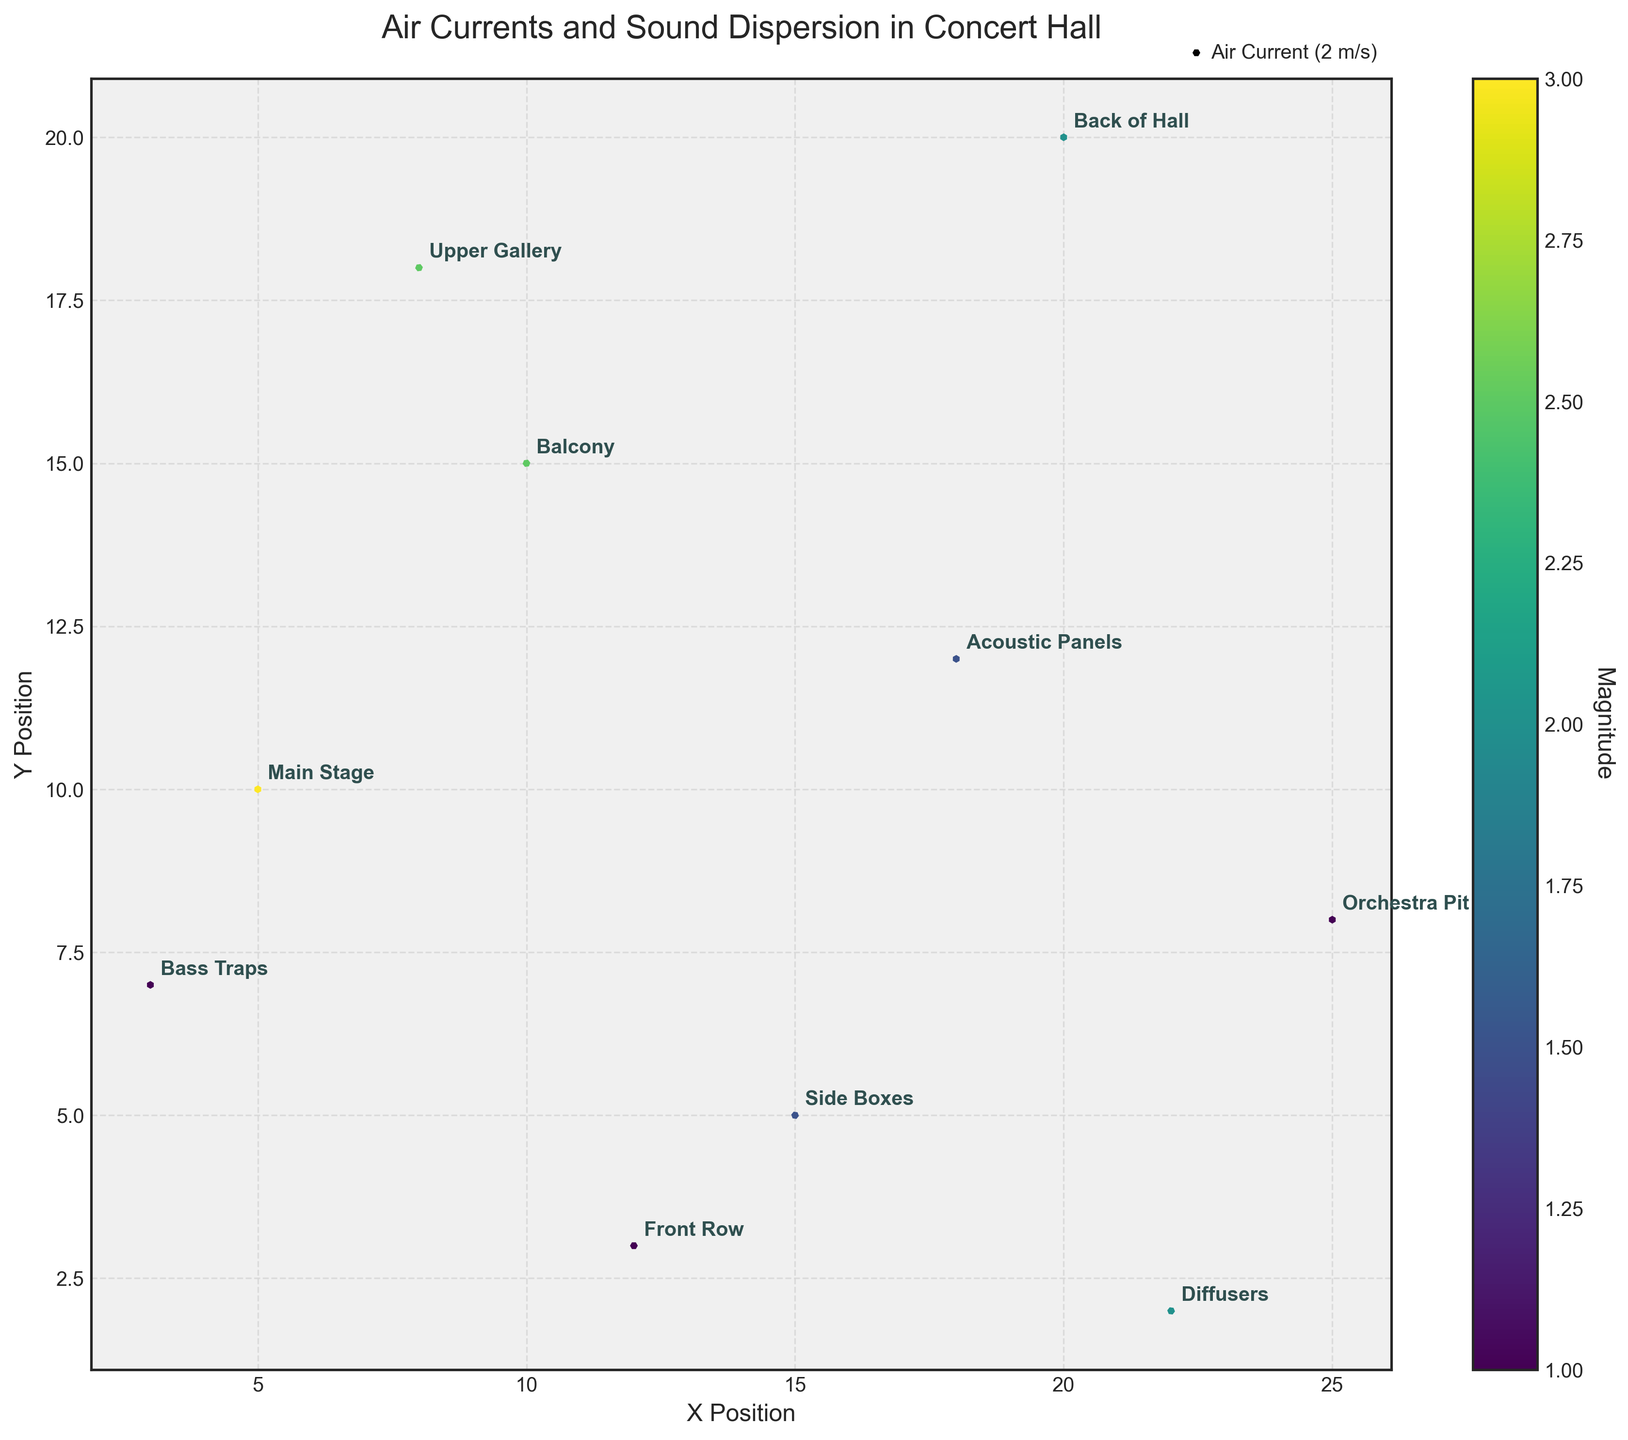What is the title of the figure? The title is typically displayed at the top of the figure in a larger font to easily describe the main content of the plot. In this case, it is 'Air Currents and Sound Dispersion in Concert Hall'.
Answer: Air Currents and Sound Dispersion in Concert Hall What are the labels on the X and Y axes? The X and Y axes labels provide context about the dimensions being measured. The X-axis is labeled 'X Position' and the Y-axis is labeled 'Y Position'.
Answer: X Position and Y Position How many data points are shown in the figure? By observing the number of arrows or labeled points in the plot, one can count each to determine the total. There are 10 data points as seen from the individual annotations like "Main Stage", "Balcony", etc.
Answer: 10 Which location has the largest air current magnitude? By examining the color intensity near the arrow and referring to the colorbar which represents the magnitude, the location labeled 'Main Stage' shows the largest value with a magnitude of 3.
Answer: Main Stage What is the direction of the air current at the 'Balcony'? The direction of the air current is depicted by the arrow pointing from the starting point. For 'Balcony', the arrow points slightly downward and to the left, indicating a direction vector of (-1, -2).
Answer: Downward and to the left What is the average magnitude of the air current for 'Main Stage' and 'Upper Gallery'? First, identify the magnitudes for both 'Main Stage' and 'Upper Gallery' from their colors and the colorbar: 3 and 2.5, respectively. Calculate the average as (3 + 2.5) / 2 = 2.75.
Answer: 2.75 Which location has an air current with no vertical component? Locate the arrows with no vertical movement (i.e. v=0). 'Front Row' is labeled and shows an air current vector of (-1, 0) indicating no vertical component.
Answer: Front Row Compare the air current direction at 'Orchestra Pit' and 'Diffusers'. Which one indicates a downward direction? Examine each arrow at 'Orchestra Pit' and 'Diffusers’. 'Orchestra Pit' points downward, whereas 'Diffusers' does not, indicating 'Orchestra Pit' has a downward direction.
Answer: Orchestra Pit How does the air current at 'Side Boxes' compare to 'Acoustic Panels'? Compare the direction and magnitude of both. 'Side Boxes' has a very small upward-rightward vector (1,1) while 'Acoustic Panels' has a larger downward-rightward vector (2, -1). The air current at 'Acoustic Panels' is slightly stronger and downward.
Answer: Stronger and downward at 'Acoustic Panels' What is the air current vector at the 'Bass Traps'? Read off the u and v components directly from the arrow: (0, 1), indicating a purely vertical upward movement.
Answer: (0, 1) 